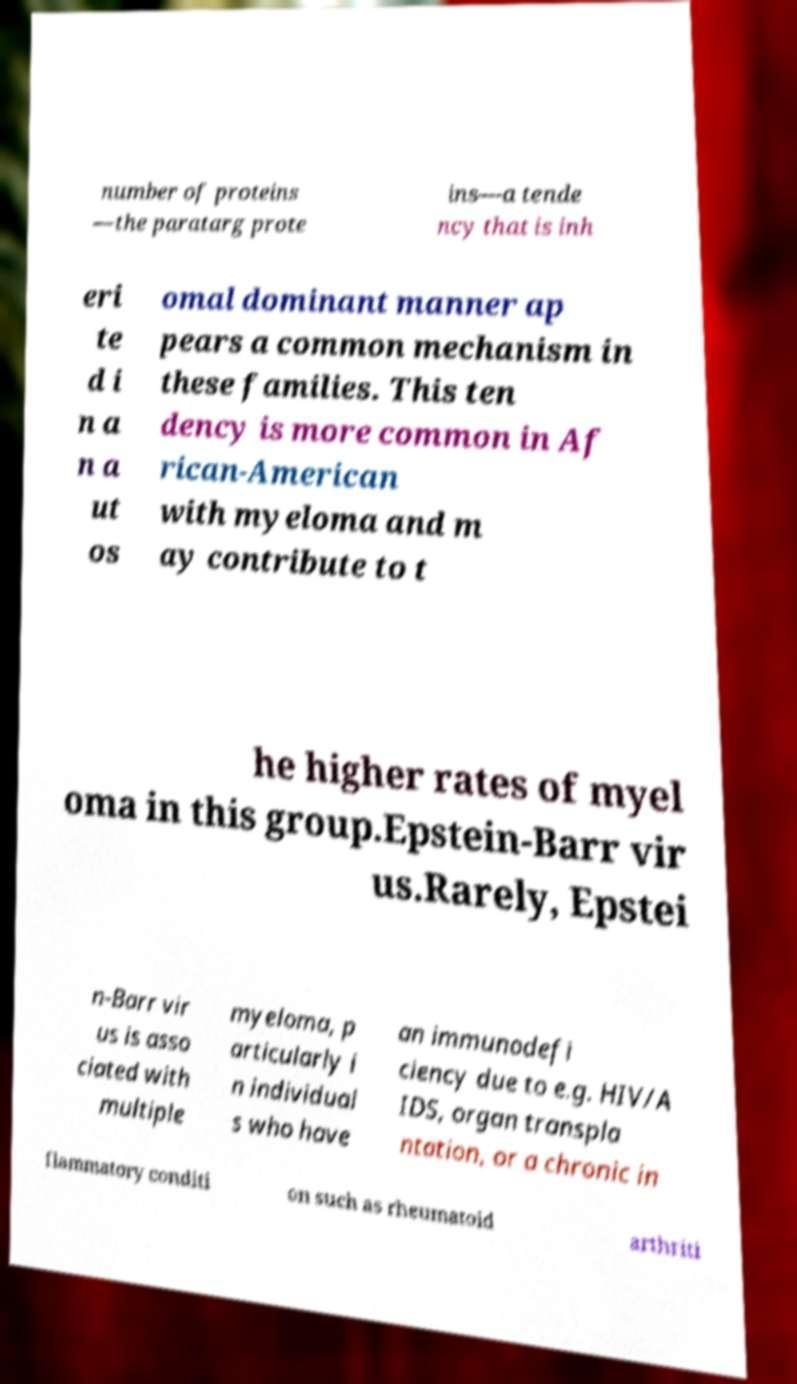I need the written content from this picture converted into text. Can you do that? number of proteins —the paratarg prote ins—a tende ncy that is inh eri te d i n a n a ut os omal dominant manner ap pears a common mechanism in these families. This ten dency is more common in Af rican-American with myeloma and m ay contribute to t he higher rates of myel oma in this group.Epstein-Barr vir us.Rarely, Epstei n-Barr vir us is asso ciated with multiple myeloma, p articularly i n individual s who have an immunodefi ciency due to e.g. HIV/A IDS, organ transpla ntation, or a chronic in flammatory conditi on such as rheumatoid arthriti 